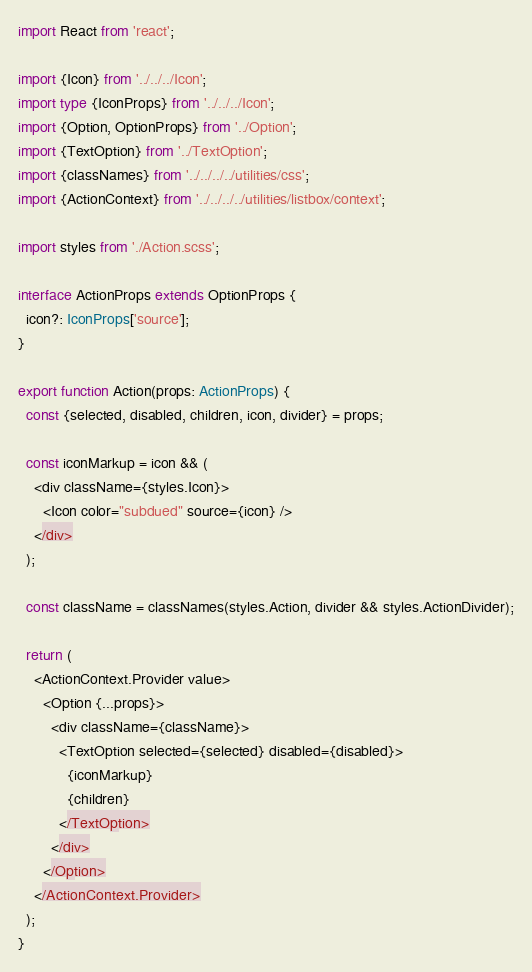<code> <loc_0><loc_0><loc_500><loc_500><_TypeScript_>import React from 'react';

import {Icon} from '../../../Icon';
import type {IconProps} from '../../../Icon';
import {Option, OptionProps} from '../Option';
import {TextOption} from '../TextOption';
import {classNames} from '../../../../utilities/css';
import {ActionContext} from '../../../../utilities/listbox/context';

import styles from './Action.scss';

interface ActionProps extends OptionProps {
  icon?: IconProps['source'];
}

export function Action(props: ActionProps) {
  const {selected, disabled, children, icon, divider} = props;

  const iconMarkup = icon && (
    <div className={styles.Icon}>
      <Icon color="subdued" source={icon} />
    </div>
  );

  const className = classNames(styles.Action, divider && styles.ActionDivider);

  return (
    <ActionContext.Provider value>
      <Option {...props}>
        <div className={className}>
          <TextOption selected={selected} disabled={disabled}>
            {iconMarkup}
            {children}
          </TextOption>
        </div>
      </Option>
    </ActionContext.Provider>
  );
}
</code> 